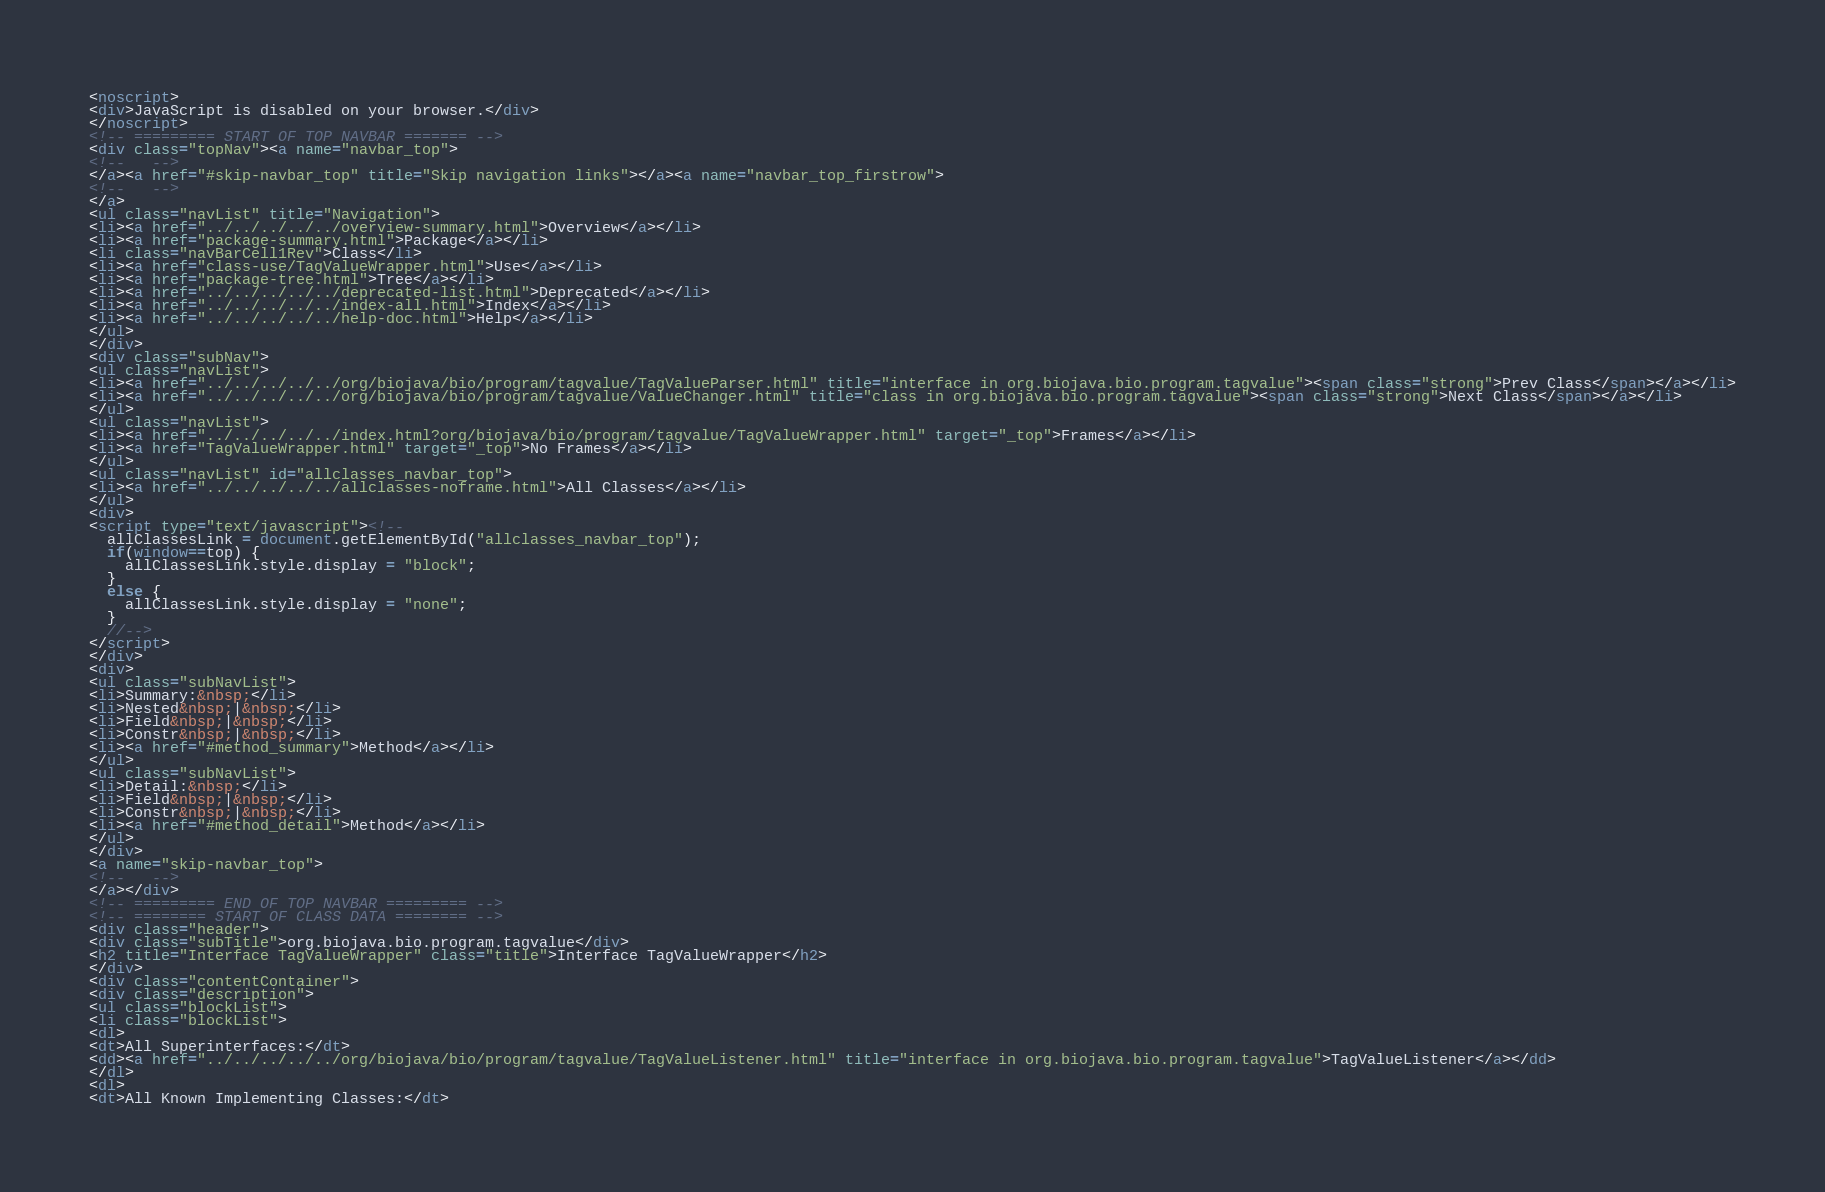<code> <loc_0><loc_0><loc_500><loc_500><_HTML_><noscript>
<div>JavaScript is disabled on your browser.</div>
</noscript>
<!-- ========= START OF TOP NAVBAR ======= -->
<div class="topNav"><a name="navbar_top">
<!--   -->
</a><a href="#skip-navbar_top" title="Skip navigation links"></a><a name="navbar_top_firstrow">
<!--   -->
</a>
<ul class="navList" title="Navigation">
<li><a href="../../../../../overview-summary.html">Overview</a></li>
<li><a href="package-summary.html">Package</a></li>
<li class="navBarCell1Rev">Class</li>
<li><a href="class-use/TagValueWrapper.html">Use</a></li>
<li><a href="package-tree.html">Tree</a></li>
<li><a href="../../../../../deprecated-list.html">Deprecated</a></li>
<li><a href="../../../../../index-all.html">Index</a></li>
<li><a href="../../../../../help-doc.html">Help</a></li>
</ul>
</div>
<div class="subNav">
<ul class="navList">
<li><a href="../../../../../org/biojava/bio/program/tagvalue/TagValueParser.html" title="interface in org.biojava.bio.program.tagvalue"><span class="strong">Prev Class</span></a></li>
<li><a href="../../../../../org/biojava/bio/program/tagvalue/ValueChanger.html" title="class in org.biojava.bio.program.tagvalue"><span class="strong">Next Class</span></a></li>
</ul>
<ul class="navList">
<li><a href="../../../../../index.html?org/biojava/bio/program/tagvalue/TagValueWrapper.html" target="_top">Frames</a></li>
<li><a href="TagValueWrapper.html" target="_top">No Frames</a></li>
</ul>
<ul class="navList" id="allclasses_navbar_top">
<li><a href="../../../../../allclasses-noframe.html">All Classes</a></li>
</ul>
<div>
<script type="text/javascript"><!--
  allClassesLink = document.getElementById("allclasses_navbar_top");
  if(window==top) {
    allClassesLink.style.display = "block";
  }
  else {
    allClassesLink.style.display = "none";
  }
  //-->
</script>
</div>
<div>
<ul class="subNavList">
<li>Summary:&nbsp;</li>
<li>Nested&nbsp;|&nbsp;</li>
<li>Field&nbsp;|&nbsp;</li>
<li>Constr&nbsp;|&nbsp;</li>
<li><a href="#method_summary">Method</a></li>
</ul>
<ul class="subNavList">
<li>Detail:&nbsp;</li>
<li>Field&nbsp;|&nbsp;</li>
<li>Constr&nbsp;|&nbsp;</li>
<li><a href="#method_detail">Method</a></li>
</ul>
</div>
<a name="skip-navbar_top">
<!--   -->
</a></div>
<!-- ========= END OF TOP NAVBAR ========= -->
<!-- ======== START OF CLASS DATA ======== -->
<div class="header">
<div class="subTitle">org.biojava.bio.program.tagvalue</div>
<h2 title="Interface TagValueWrapper" class="title">Interface TagValueWrapper</h2>
</div>
<div class="contentContainer">
<div class="description">
<ul class="blockList">
<li class="blockList">
<dl>
<dt>All Superinterfaces:</dt>
<dd><a href="../../../../../org/biojava/bio/program/tagvalue/TagValueListener.html" title="interface in org.biojava.bio.program.tagvalue">TagValueListener</a></dd>
</dl>
<dl>
<dt>All Known Implementing Classes:</dt></code> 